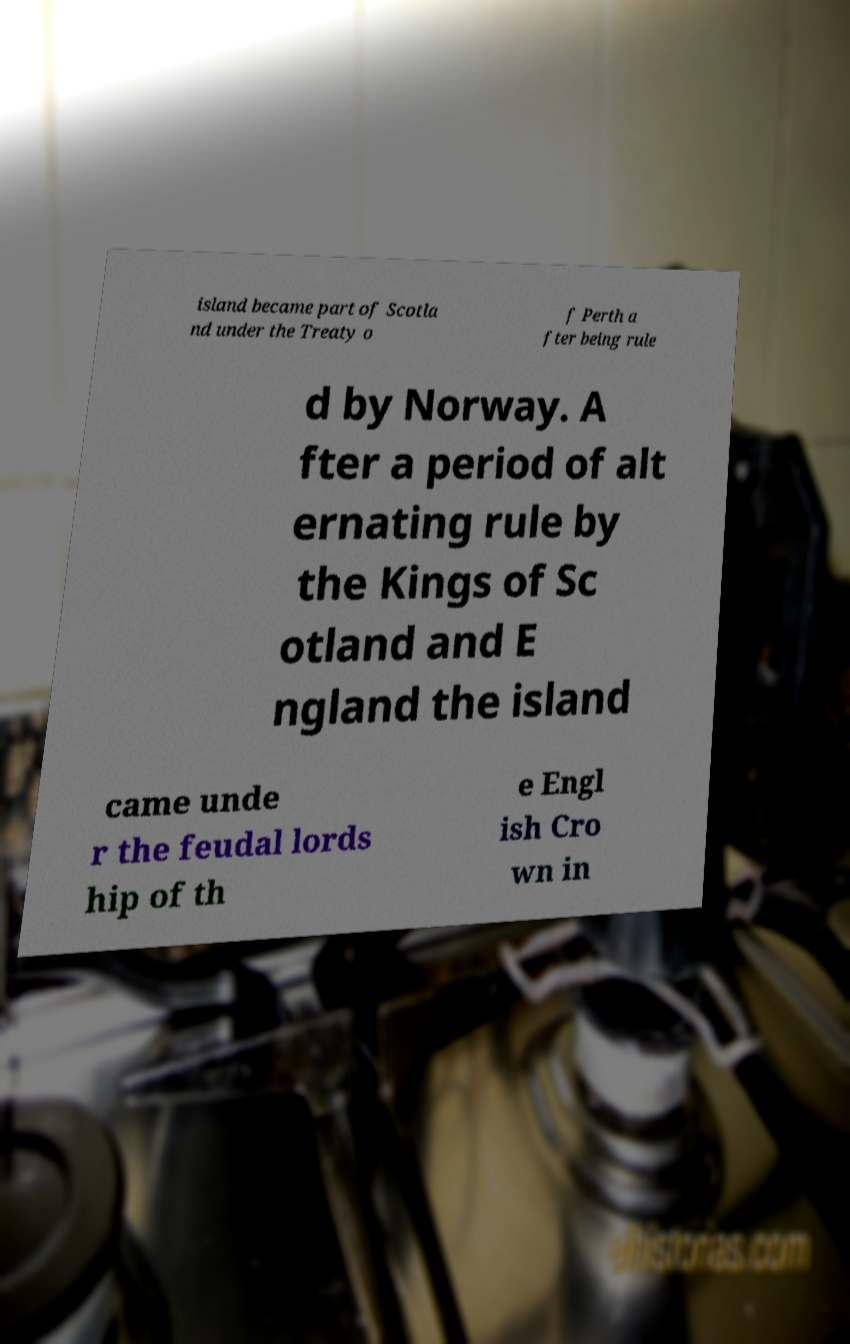What messages or text are displayed in this image? I need them in a readable, typed format. island became part of Scotla nd under the Treaty o f Perth a fter being rule d by Norway. A fter a period of alt ernating rule by the Kings of Sc otland and E ngland the island came unde r the feudal lords hip of th e Engl ish Cro wn in 